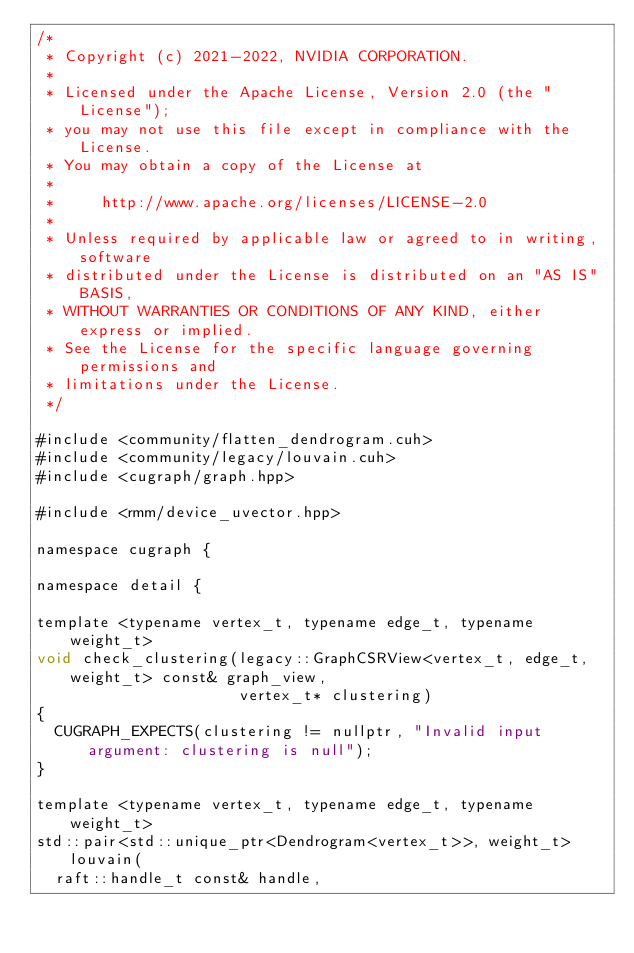Convert code to text. <code><loc_0><loc_0><loc_500><loc_500><_Cuda_>/*
 * Copyright (c) 2021-2022, NVIDIA CORPORATION.
 *
 * Licensed under the Apache License, Version 2.0 (the "License");
 * you may not use this file except in compliance with the License.
 * You may obtain a copy of the License at
 *
 *     http://www.apache.org/licenses/LICENSE-2.0
 *
 * Unless required by applicable law or agreed to in writing, software
 * distributed under the License is distributed on an "AS IS" BASIS,
 * WITHOUT WARRANTIES OR CONDITIONS OF ANY KIND, either express or implied.
 * See the License for the specific language governing permissions and
 * limitations under the License.
 */

#include <community/flatten_dendrogram.cuh>
#include <community/legacy/louvain.cuh>
#include <cugraph/graph.hpp>

#include <rmm/device_uvector.hpp>

namespace cugraph {

namespace detail {

template <typename vertex_t, typename edge_t, typename weight_t>
void check_clustering(legacy::GraphCSRView<vertex_t, edge_t, weight_t> const& graph_view,
                      vertex_t* clustering)
{
  CUGRAPH_EXPECTS(clustering != nullptr, "Invalid input argument: clustering is null");
}

template <typename vertex_t, typename edge_t, typename weight_t>
std::pair<std::unique_ptr<Dendrogram<vertex_t>>, weight_t> louvain(
  raft::handle_t const& handle,</code> 